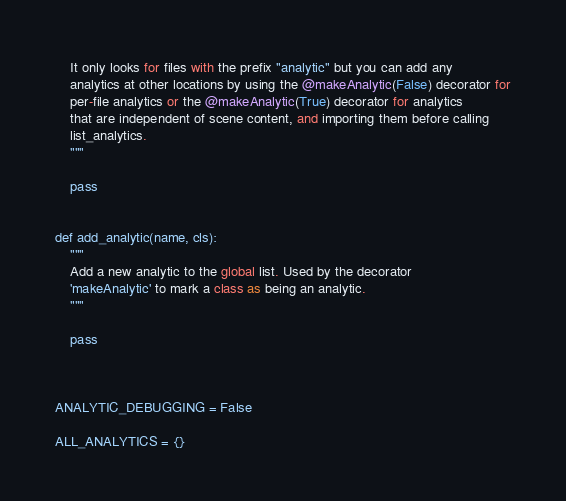Convert code to text. <code><loc_0><loc_0><loc_500><loc_500><_Python_>    It only looks for files with the prefix "analytic" but you can add any
    analytics at other locations by using the @makeAnalytic(False) decorator for
    per-file analytics or the @makeAnalytic(True) decorator for analytics
    that are independent of scene content, and importing them before calling
    list_analytics.
    """

    pass


def add_analytic(name, cls):
    """
    Add a new analytic to the global list. Used by the decorator
    'makeAnalytic' to mark a class as being an analytic.
    """

    pass



ANALYTIC_DEBUGGING = False

ALL_ANALYTICS = {}


</code> 